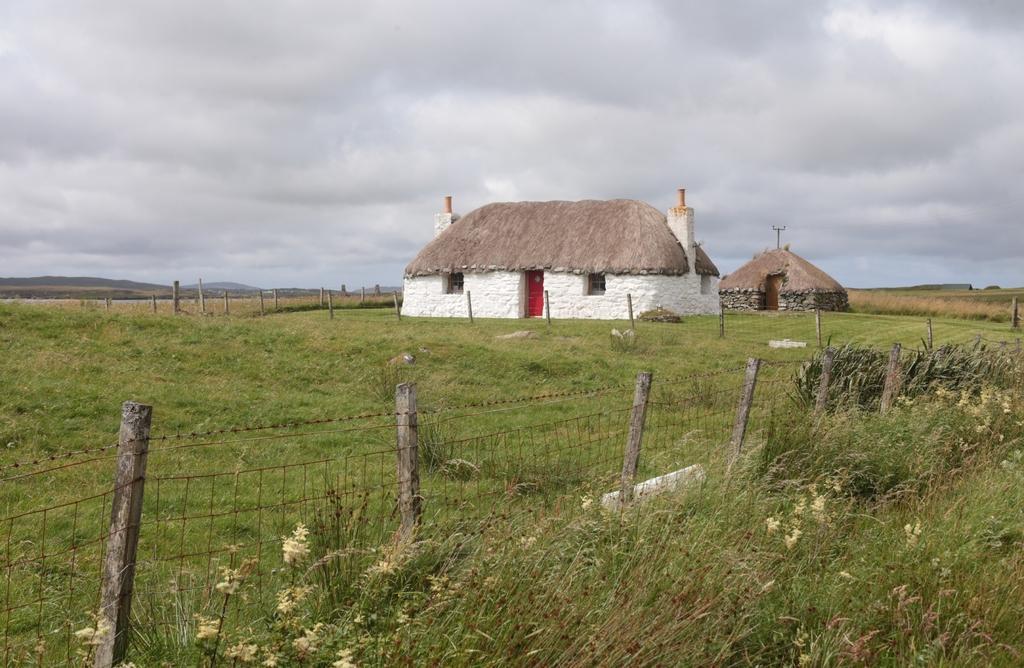Could you give a brief overview of what you see in this image? This picture is clicked outside. In the foreground we can see the fence, grass and plants. In the center we can see the huts. In the background there is a sky and we can see the hills. 